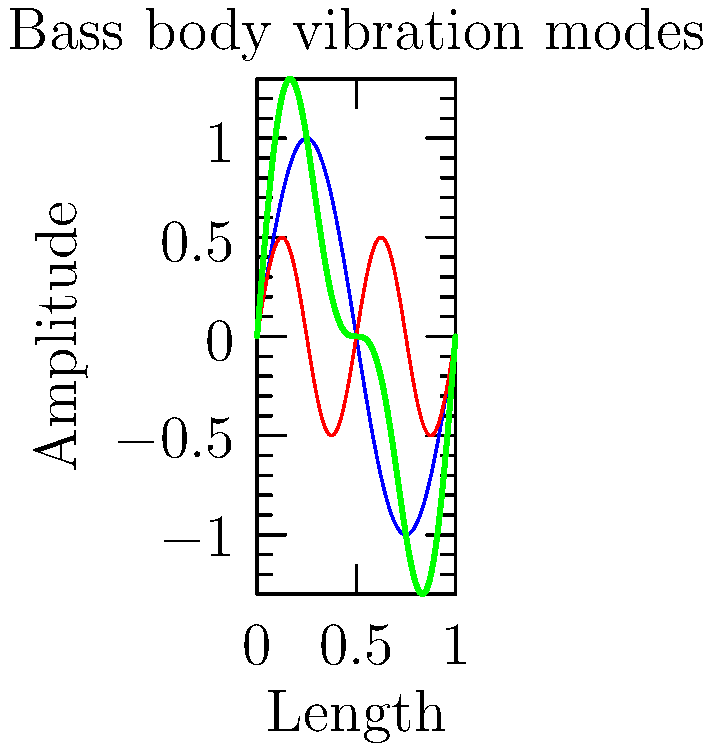As a bassist, you're interested in understanding the vibration modes of your instrument. The graph shows the first two vibration modes of a bass guitar body and their combination. If the fundamental frequency of the first mode is 110 Hz, what is the frequency of the second mode shown in the graph? To solve this problem, we need to analyze the graph and understand the relationship between the two vibration modes:

1. The blue curve represents the first vibration mode (fundamental frequency).
2. The red curve represents the second vibration mode.
3. The green curve shows the combination of both modes.

We can observe that:
1. The first mode (blue) completes one full cycle over the length of the bass body.
2. The second mode (red) completes two full cycles over the same length.

The relationship between frequency and wavelength is given by the equation:
$$ f = \frac{v}{\lambda} $$
Where $f$ is frequency, $v$ is wave velocity, and $\lambda$ is wavelength.

Since the wave velocity is constant for both modes (it depends on the material properties of the bass body), we can establish a relationship between the frequencies:

$$ \frac{f_1}{\lambda_1} = \frac{f_2}{\lambda_2} $$

We know that $\lambda_2 = \frac{1}{2}\lambda_1$ (the second mode has half the wavelength of the first mode).

Substituting this into the equation:

$$ \frac{f_1}{\lambda_1} = \frac{f_2}{\frac{1}{2}\lambda_1} $$

Simplifying:

$$ f_1 = \frac{1}{2}f_2 $$

Therefore:

$$ f_2 = 2f_1 $$

Given that the fundamental frequency (first mode) is 110 Hz:

$$ f_2 = 2 \times 110\text{ Hz} = 220\text{ Hz} $$
Answer: 220 Hz 